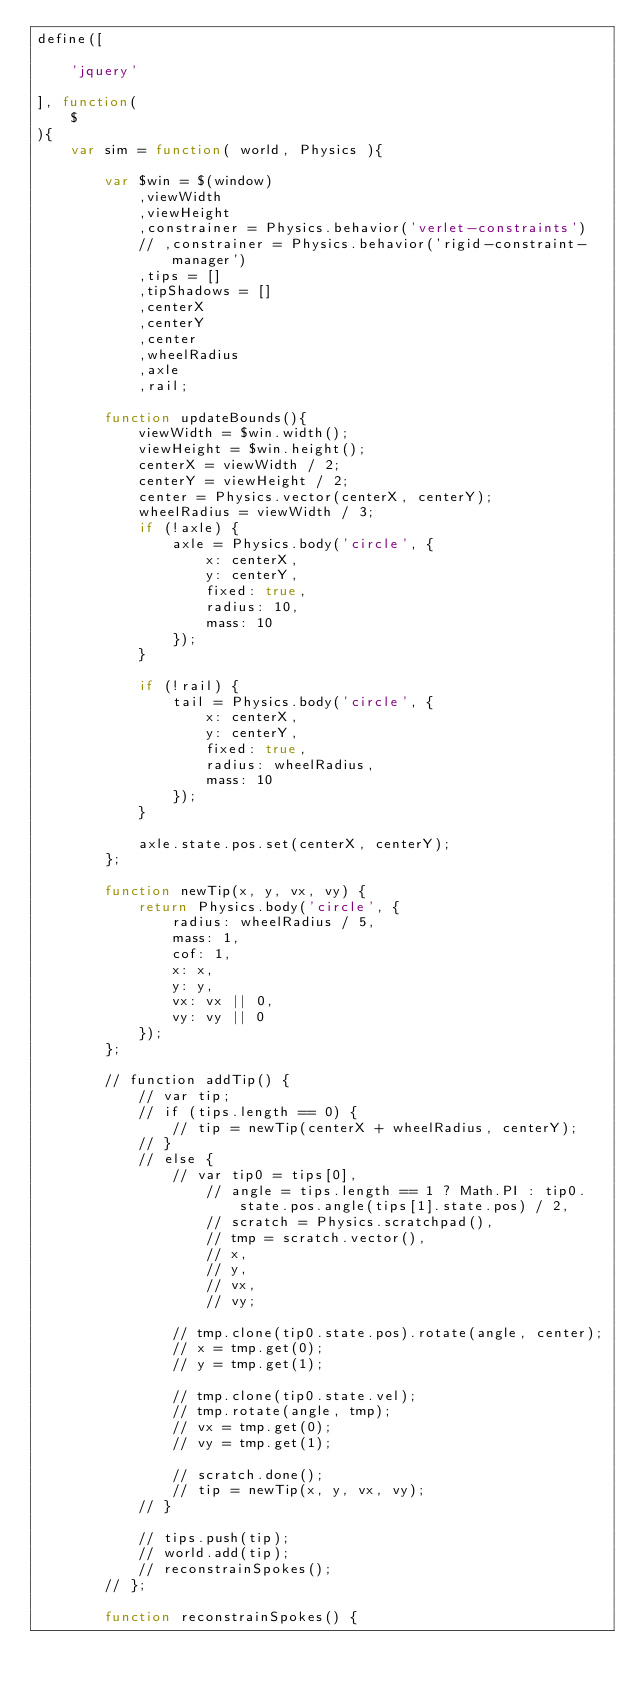Convert code to text. <code><loc_0><loc_0><loc_500><loc_500><_JavaScript_>define([
    
    'jquery'

], function(
    $
){
    var sim = function( world, Physics ){

        var $win = $(window)
            ,viewWidth
            ,viewHeight
			,constrainer = Physics.behavior('verlet-constraints')
			// ,constrainer = Physics.behavior('rigid-constraint-manager')
			,tips = []
			,tipShadows = []
			,centerX
			,centerY
			,center
			,wheelRadius
			,axle
			,rail;

		function updateBounds(){
            viewWidth = $win.width();
            viewHeight = $win.height();
			centerX = viewWidth / 2;
			centerY = viewHeight / 2;
			center = Physics.vector(centerX, centerY);
			wheelRadius = viewWidth / 3;
			if (!axle) {
				axle = Physics.body('circle', {
					x: centerX,
					y: centerY,
					fixed: true,
					radius: 10,
					mass: 10
				});
			}
			
			if (!rail) {
				tail = Physics.body('circle', {
					x: centerX,
					y: centerY,
					fixed: true,
					radius: wheelRadius,
					mass: 10
				});
			}
			
			axle.state.pos.set(centerX, centerY);
        };
		
		function newTip(x, y, vx, vy) {
			return Physics.body('circle', {
				radius: wheelRadius / 5,
				mass: 1,
				cof: 1,
				x: x,
				y: y,
				vx: vx || 0,
				vy: vy || 0
			});
		};
		
		// function addTip() {
			// var tip;
			// if (tips.length == 0) {
				// tip = newTip(centerX + wheelRadius, centerY);
			// }
			// else {
				// var tip0 = tips[0],
					// angle = tips.length == 1 ? Math.PI : tip0.state.pos.angle(tips[1].state.pos) / 2,
					// scratch = Physics.scratchpad(),
					// tmp = scratch.vector(),
					// x, 
					// y, 
					// vx, 
					// vy;
					
				// tmp.clone(tip0.state.pos).rotate(angle, center);
				// x = tmp.get(0);
				// y = tmp.get(1);
				
				// tmp.clone(tip0.state.vel);
				// tmp.rotate(angle, tmp);
				// vx = tmp.get(0);
				// vy = tmp.get(1);
				
				// scratch.done();
				// tip = newTip(x, y, vx, vy);
			// }
				
			// tips.push(tip);
			// world.add(tip);			
			// reconstrainSpokes();
		// };
		
		function reconstrainSpokes() {</code> 